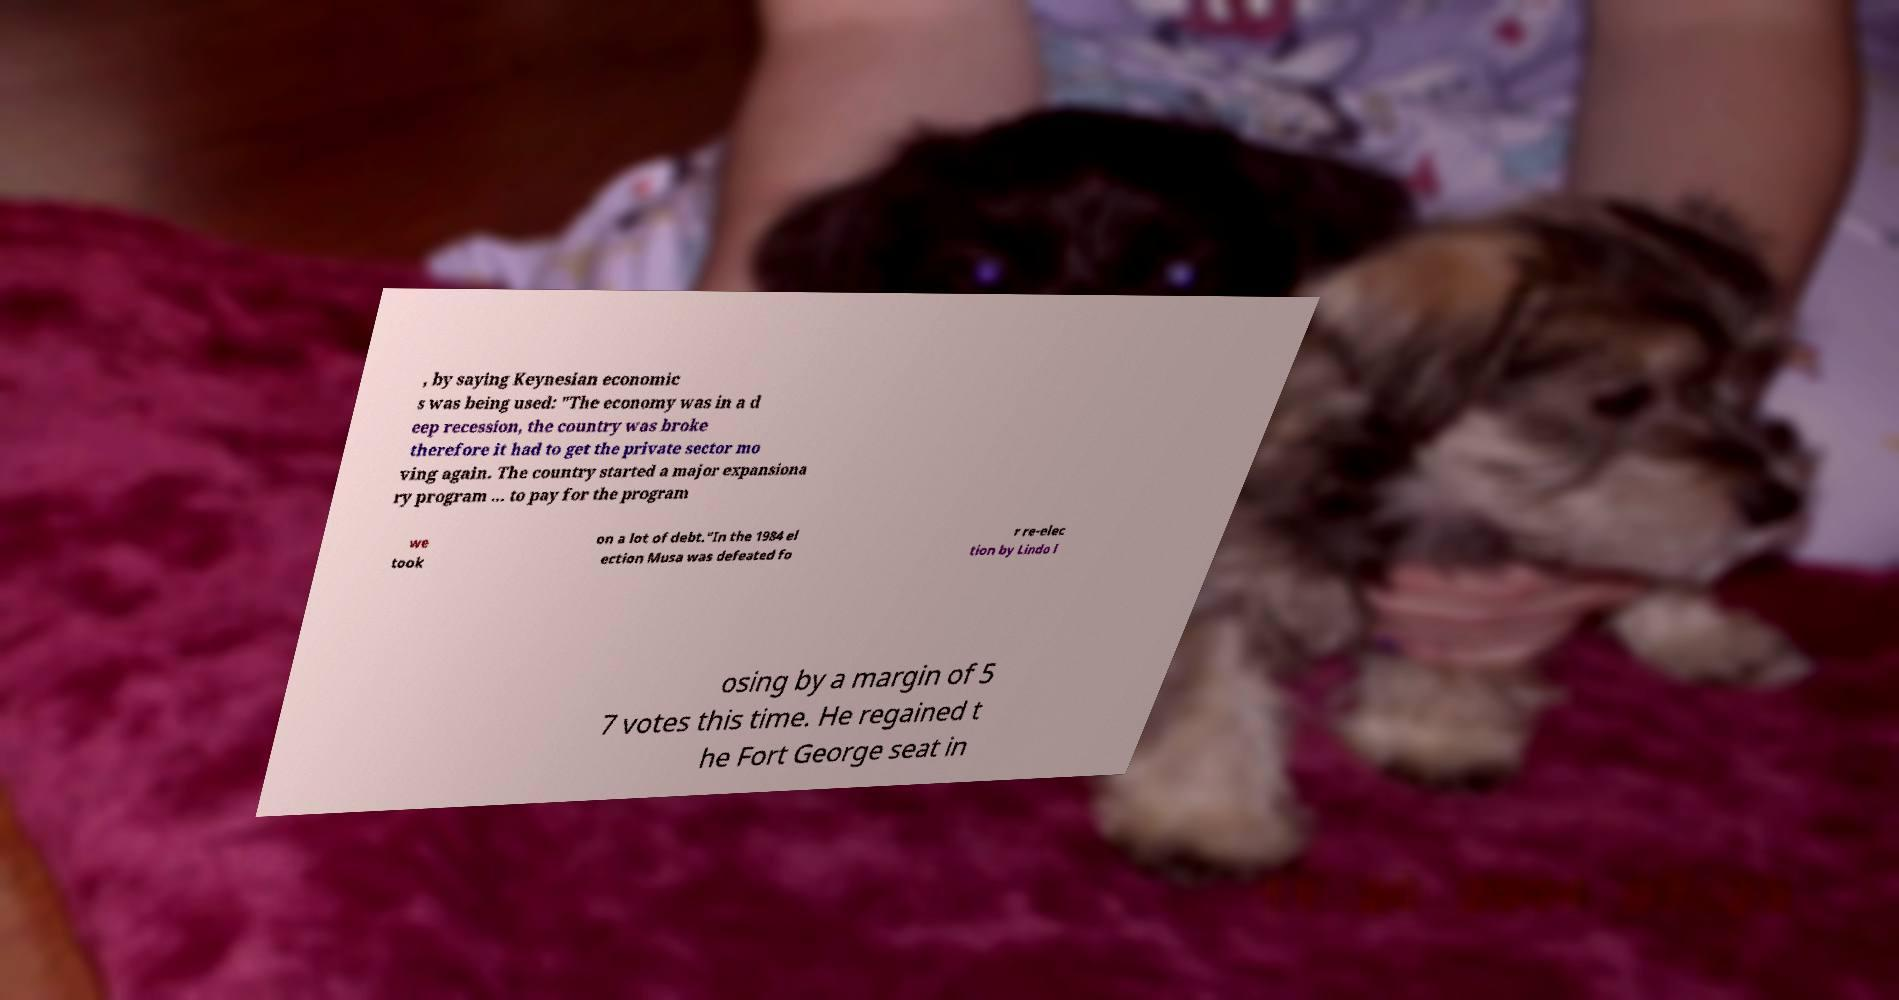Could you assist in decoding the text presented in this image and type it out clearly? , by saying Keynesian economic s was being used: "The economy was in a d eep recession, the country was broke therefore it had to get the private sector mo ving again. The country started a major expansiona ry program ... to pay for the program we took on a lot of debt."In the 1984 el ection Musa was defeated fo r re-elec tion by Lindo l osing by a margin of 5 7 votes this time. He regained t he Fort George seat in 